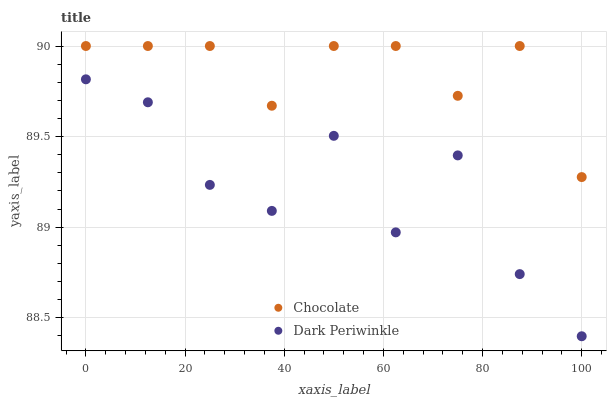Does Dark Periwinkle have the minimum area under the curve?
Answer yes or no. Yes. Does Chocolate have the maximum area under the curve?
Answer yes or no. Yes. Does Chocolate have the minimum area under the curve?
Answer yes or no. No. Is Chocolate the smoothest?
Answer yes or no. Yes. Is Dark Periwinkle the roughest?
Answer yes or no. Yes. Is Chocolate the roughest?
Answer yes or no. No. Does Dark Periwinkle have the lowest value?
Answer yes or no. Yes. Does Chocolate have the lowest value?
Answer yes or no. No. Does Chocolate have the highest value?
Answer yes or no. Yes. Is Dark Periwinkle less than Chocolate?
Answer yes or no. Yes. Is Chocolate greater than Dark Periwinkle?
Answer yes or no. Yes. Does Dark Periwinkle intersect Chocolate?
Answer yes or no. No. 